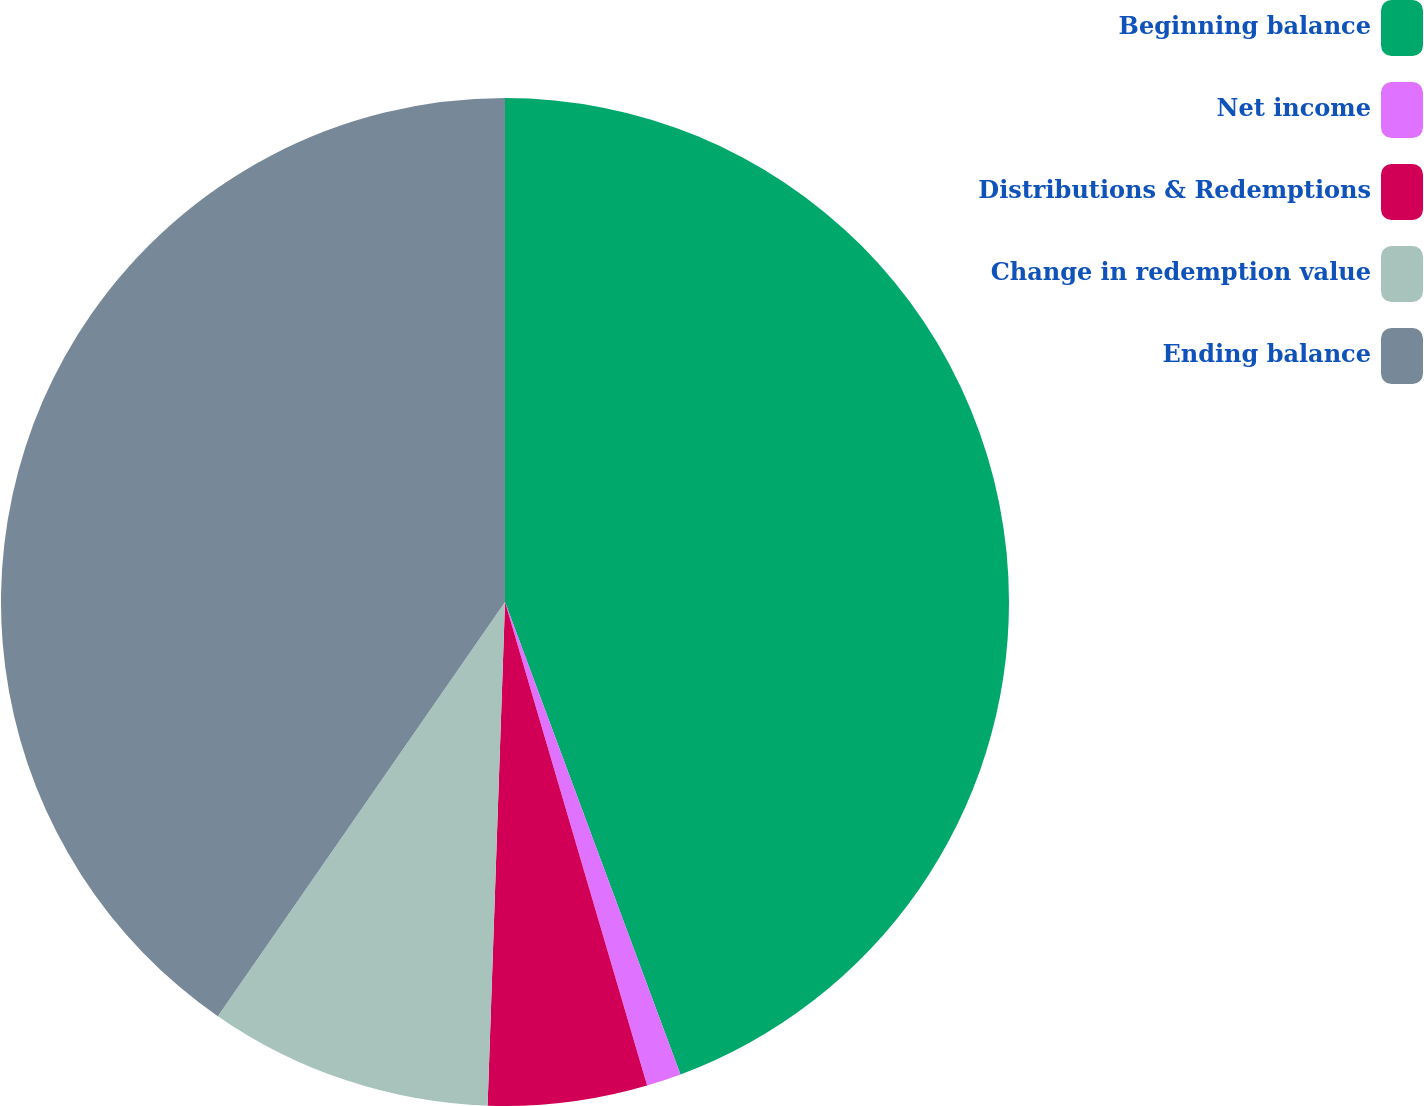Convert chart to OTSL. <chart><loc_0><loc_0><loc_500><loc_500><pie_chart><fcel>Beginning balance<fcel>Net income<fcel>Distributions & Redemptions<fcel>Change in redemption value<fcel>Ending balance<nl><fcel>44.34%<fcel>1.11%<fcel>5.1%<fcel>9.1%<fcel>40.35%<nl></chart> 